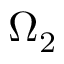<formula> <loc_0><loc_0><loc_500><loc_500>\Omega _ { 2 }</formula> 